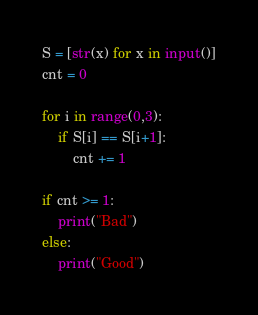Convert code to text. <code><loc_0><loc_0><loc_500><loc_500><_Python_>S = [str(x) for x in input()]
cnt = 0
 
for i in range(0,3):
    if S[i] == S[i+1]:
        cnt += 1
 
if cnt >= 1:
    print("Bad")
else:
    print("Good")</code> 